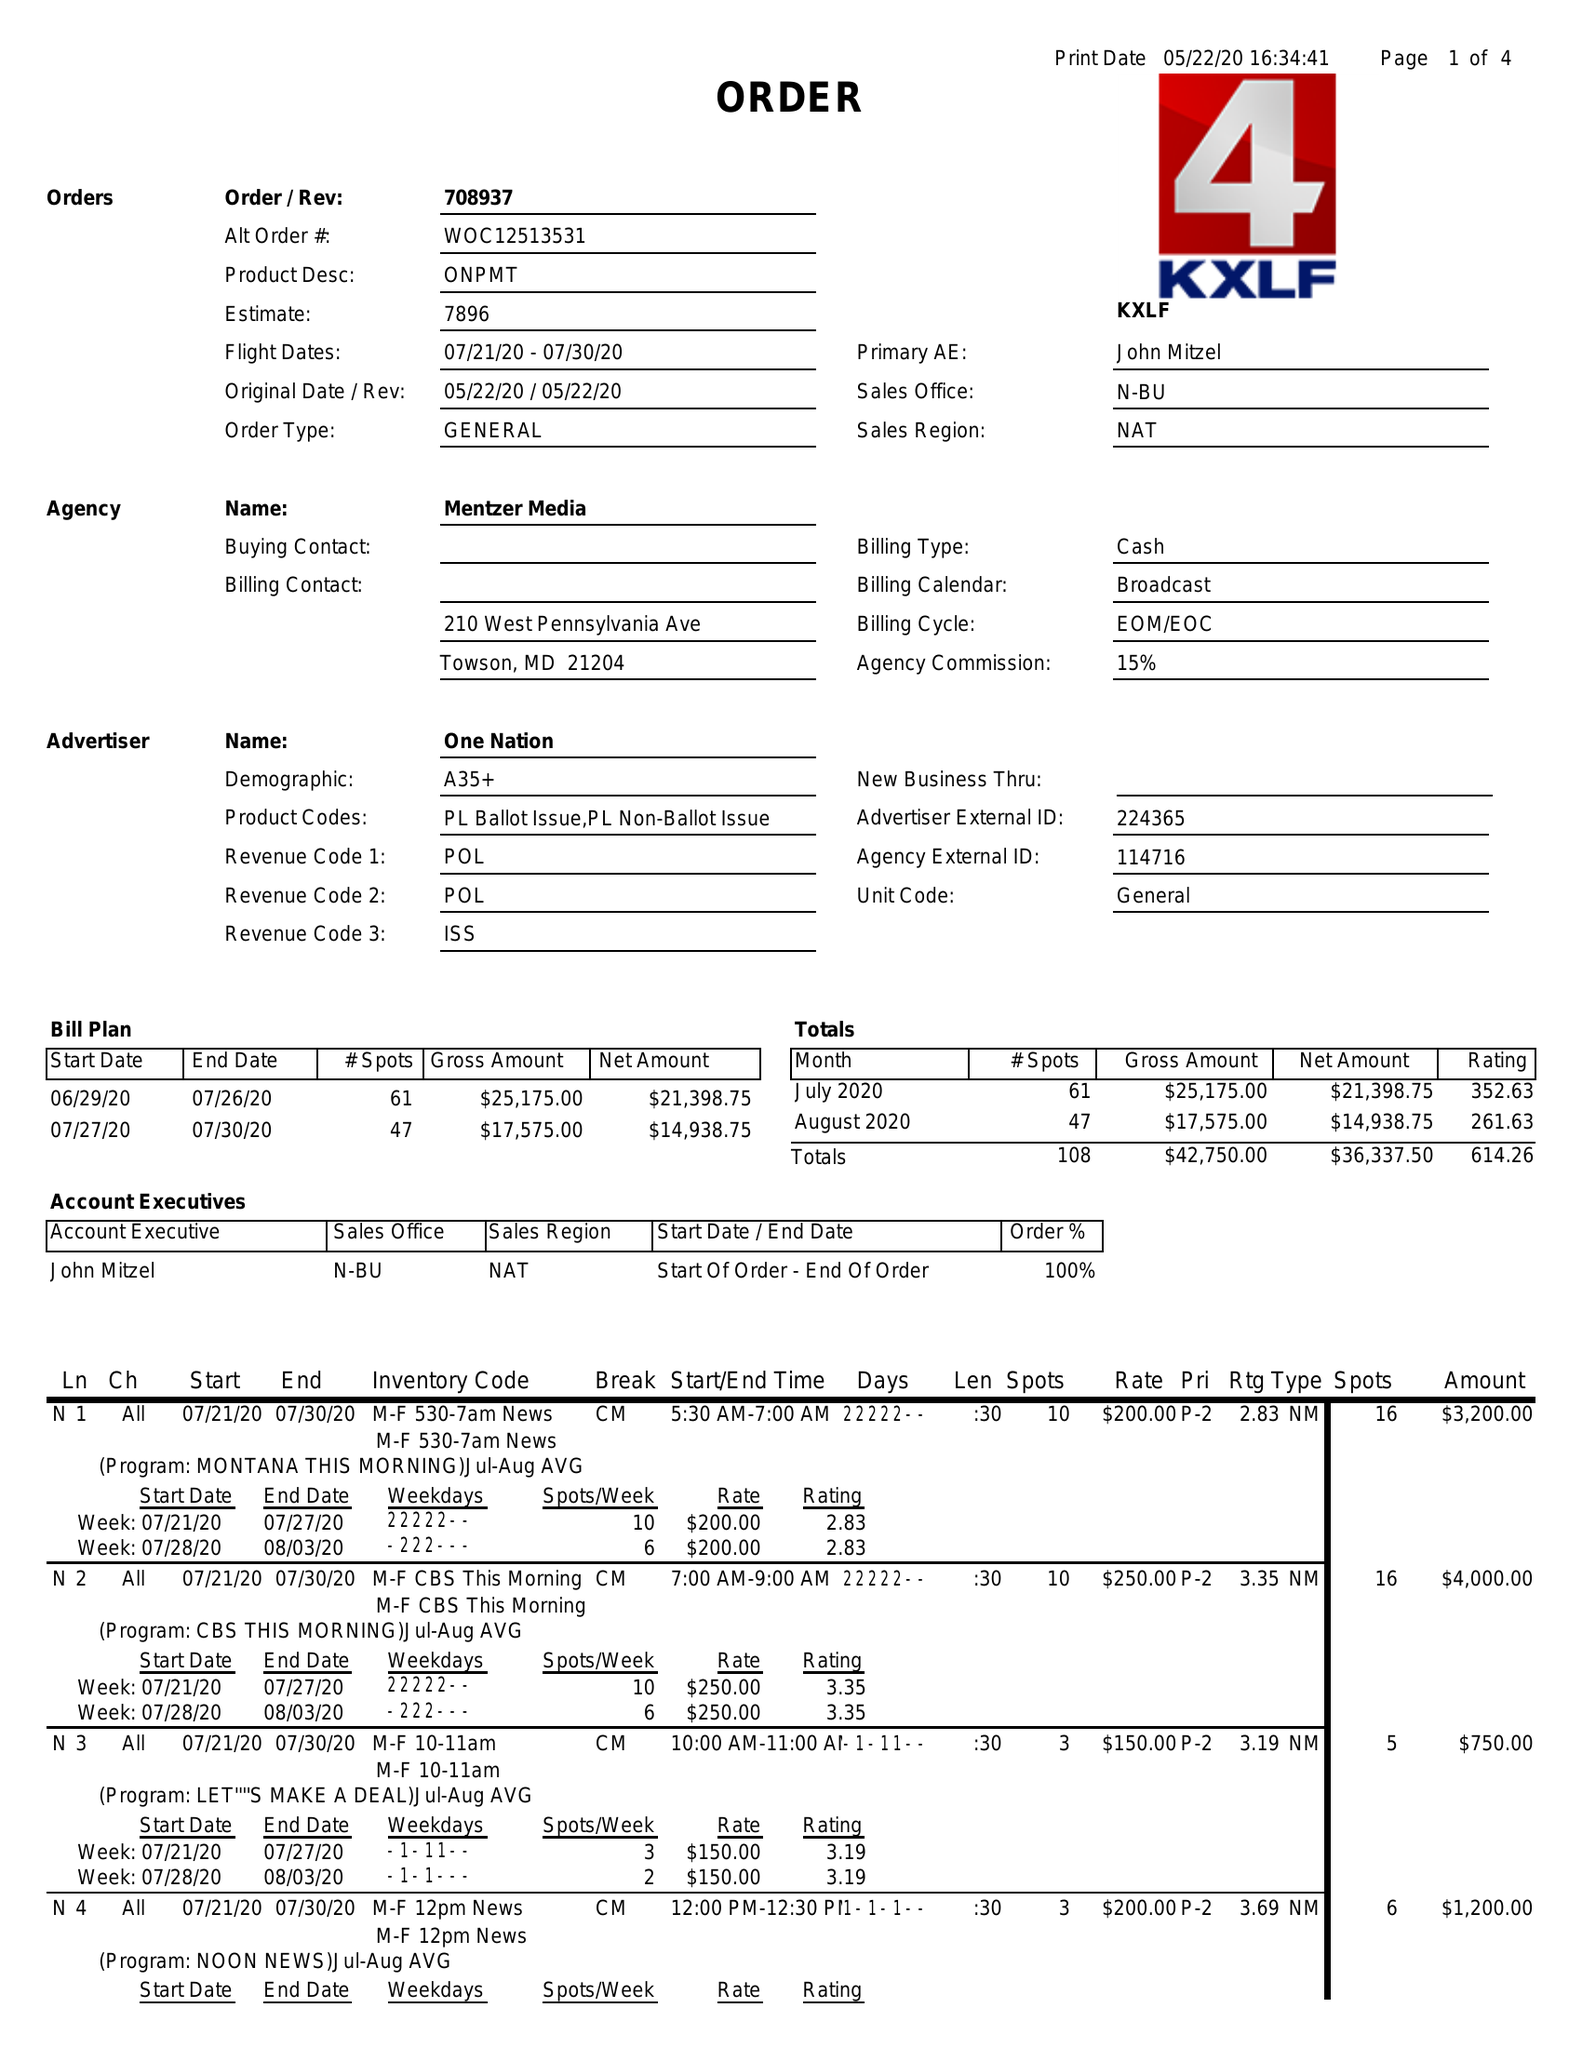What is the value for the contract_num?
Answer the question using a single word or phrase. 708937 